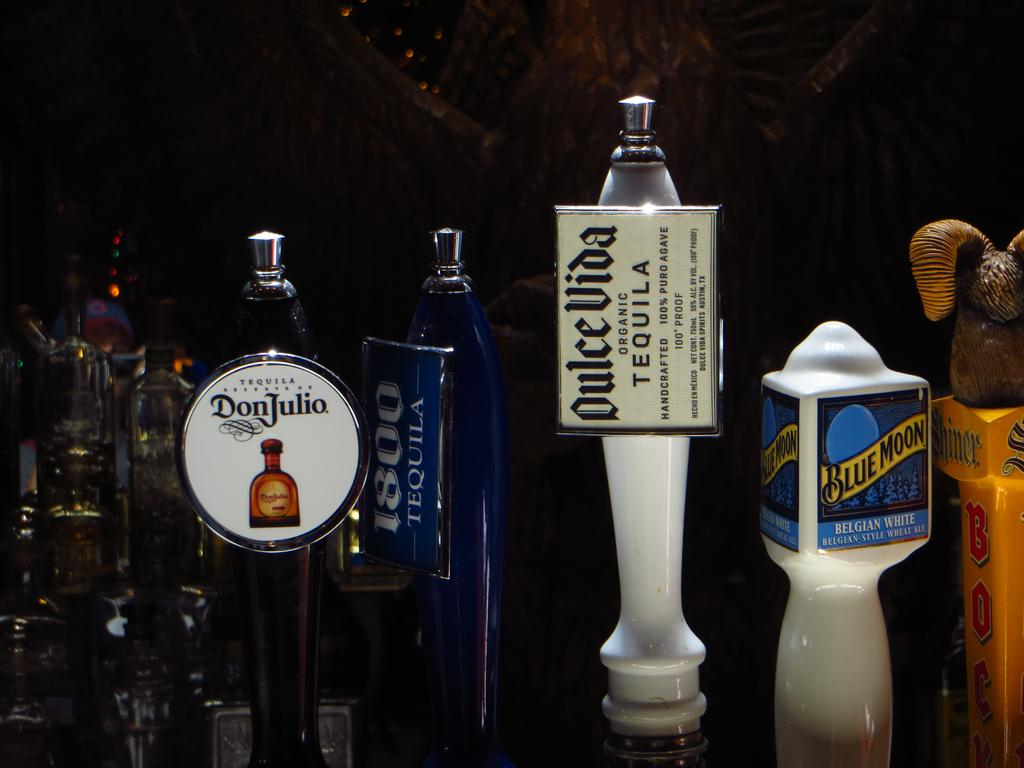<image>
Relay a brief, clear account of the picture shown. Several bottles of alcohol are arranged including one with the Don Julio Brand in a circular tag. 